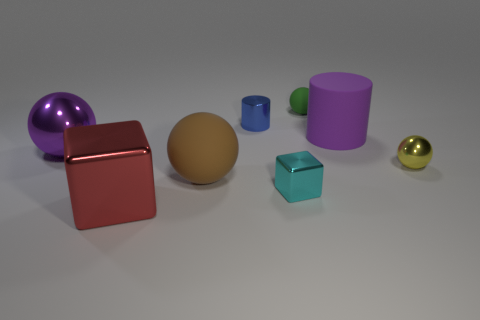There is a matte cylinder that is the same color as the big metallic ball; what is its size?
Offer a very short reply. Large. What number of things are big cyan blocks or metallic balls on the left side of the small rubber ball?
Provide a short and direct response. 1. The object that is both to the left of the tiny yellow shiny object and on the right side of the green rubber thing is what color?
Your answer should be compact. Purple. Do the purple matte object and the blue metal cylinder have the same size?
Your response must be concise. No. There is a big shiny object that is behind the large red object; what color is it?
Make the answer very short. Purple. Are there any big cubes that have the same color as the big rubber cylinder?
Offer a very short reply. No. The metal cube that is the same size as the blue metallic object is what color?
Offer a terse response. Cyan. Is the shape of the tiny yellow thing the same as the green rubber object?
Give a very brief answer. Yes. There is a object behind the small metallic cylinder; what is it made of?
Give a very brief answer. Rubber. The tiny matte sphere has what color?
Make the answer very short. Green. 